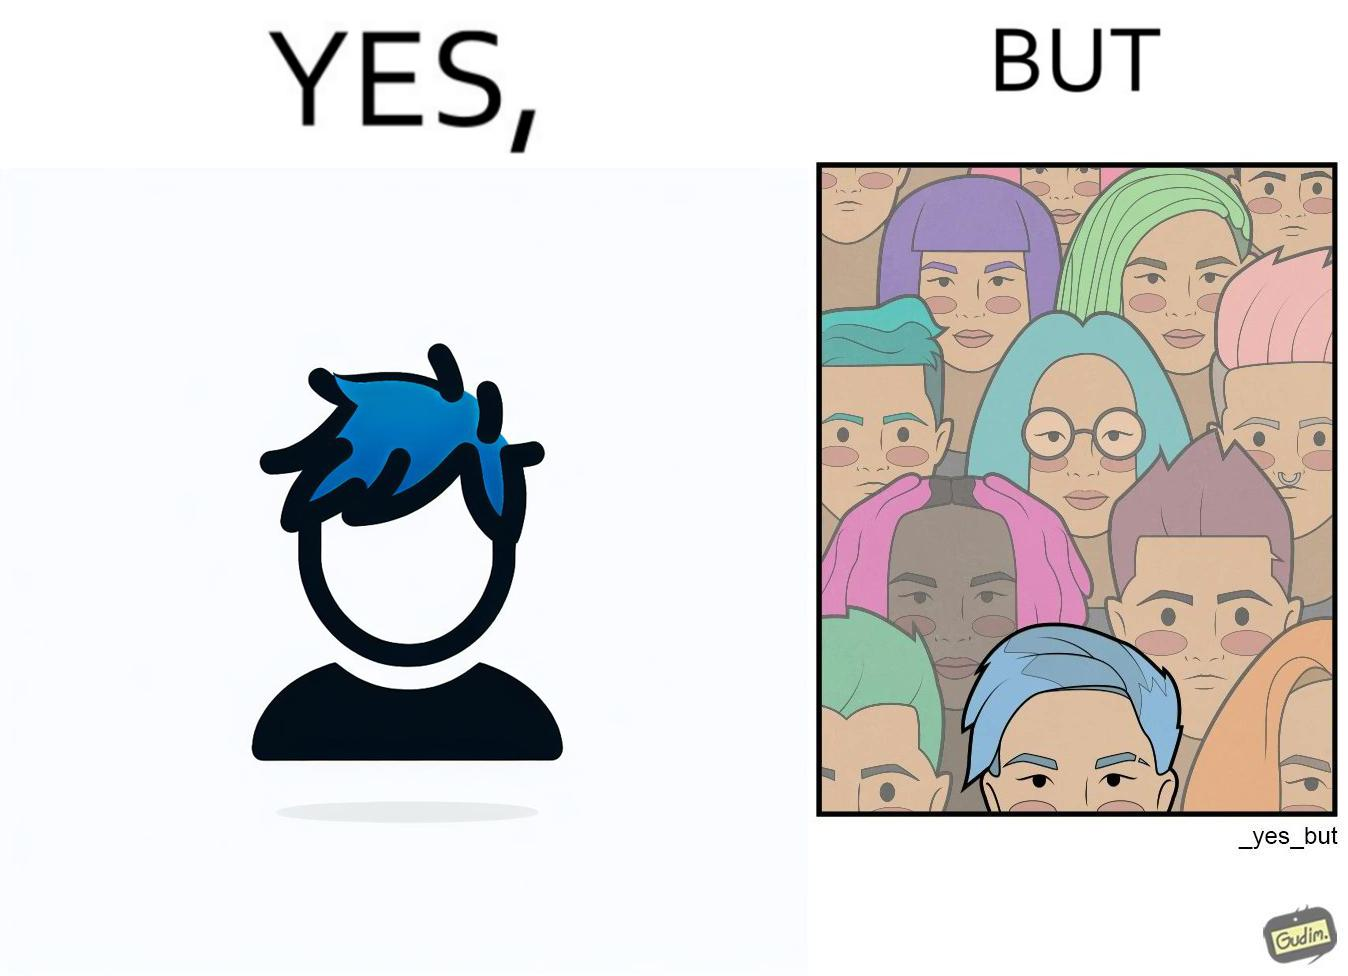Is there satirical content in this image? Yes, this image is satirical. 